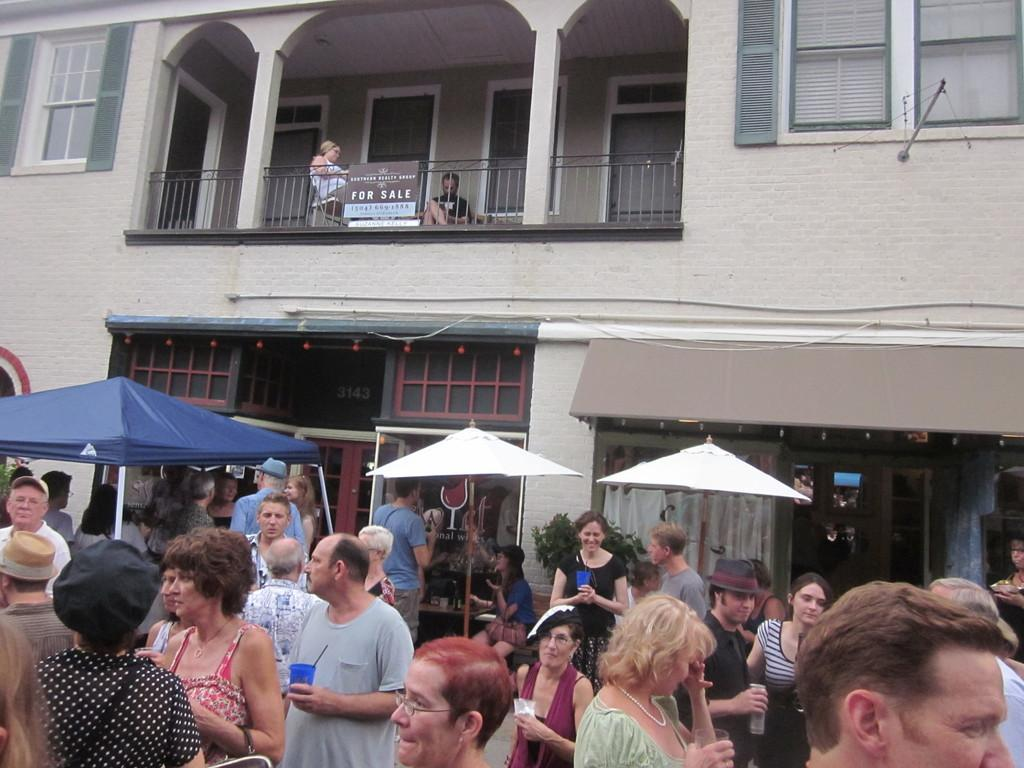<image>
Share a concise interpretation of the image provided. A for sale sign hangs above a busy crowded street. 